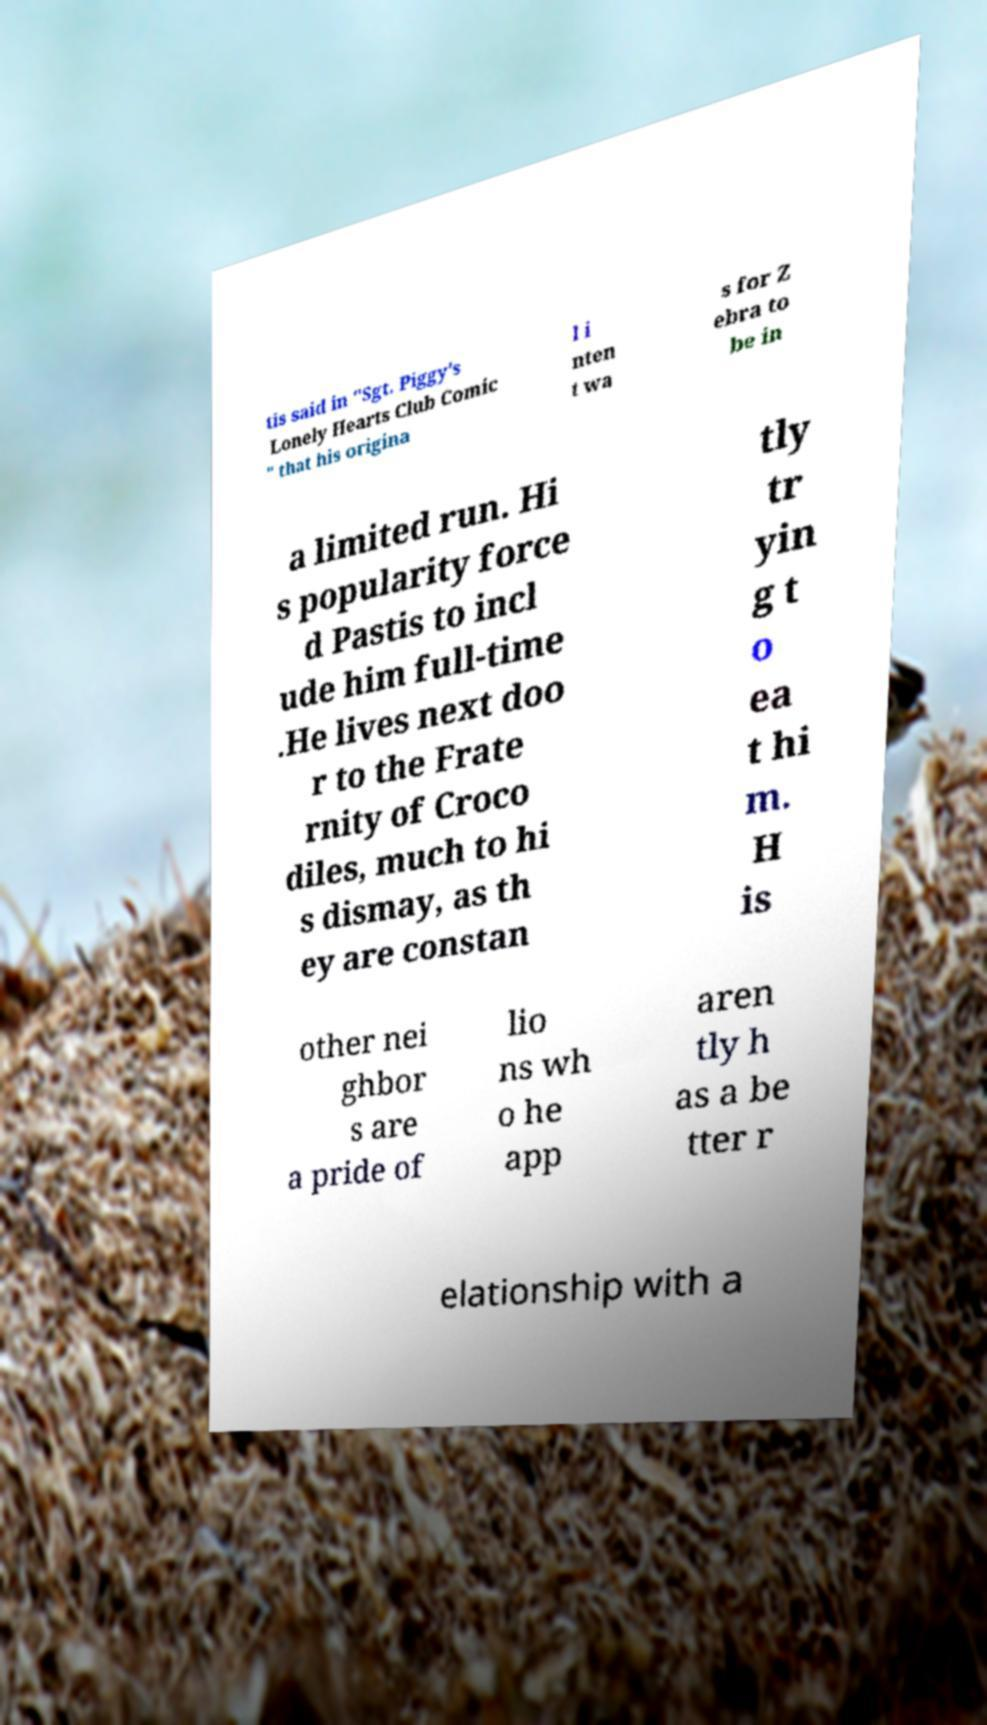Please identify and transcribe the text found in this image. tis said in "Sgt. Piggy's Lonely Hearts Club Comic " that his origina l i nten t wa s for Z ebra to be in a limited run. Hi s popularity force d Pastis to incl ude him full-time .He lives next doo r to the Frate rnity of Croco diles, much to hi s dismay, as th ey are constan tly tr yin g t o ea t hi m. H is other nei ghbor s are a pride of lio ns wh o he app aren tly h as a be tter r elationship with a 